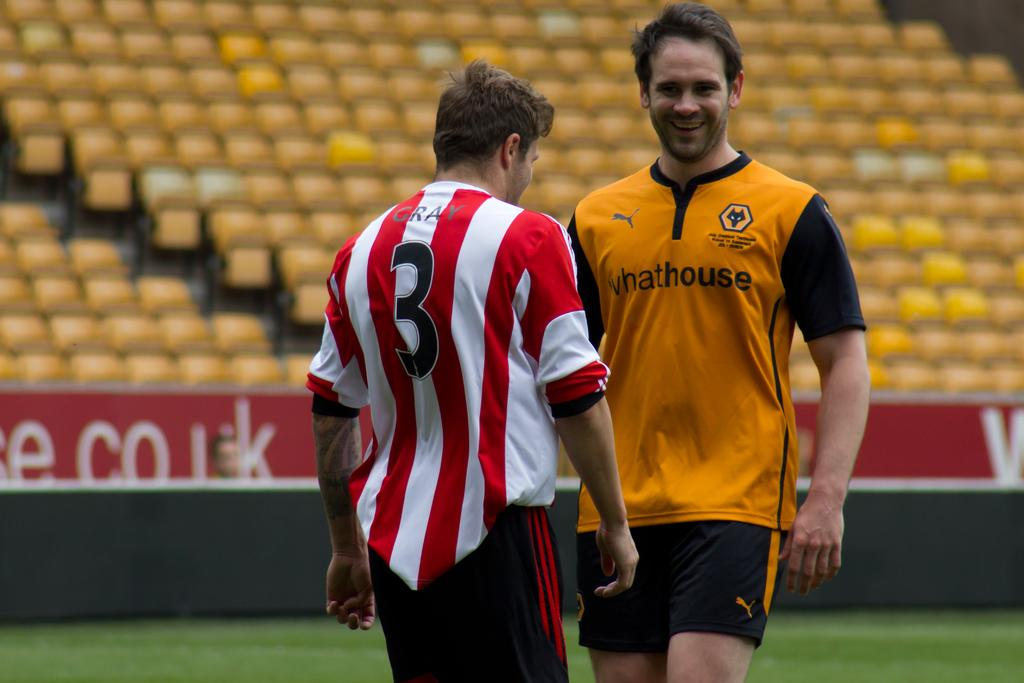<image>
Create a compact narrative representing the image presented. A player wearing a whathouse jersey laughs with player #3 from the opposite team. 